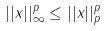Convert formula to latex. <formula><loc_0><loc_0><loc_500><loc_500>| | x | | _ { \infty } ^ { p } \leq | | x | | _ { p } ^ { p }</formula> 